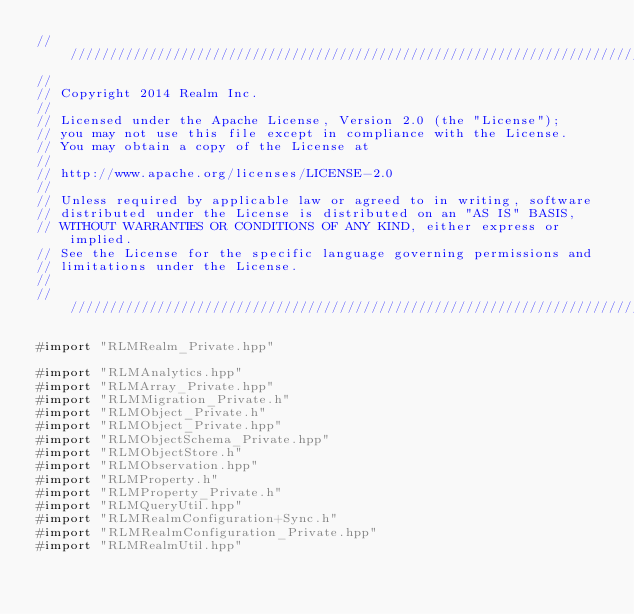Convert code to text. <code><loc_0><loc_0><loc_500><loc_500><_ObjectiveC_>////////////////////////////////////////////////////////////////////////////
//
// Copyright 2014 Realm Inc.
//
// Licensed under the Apache License, Version 2.0 (the "License");
// you may not use this file except in compliance with the License.
// You may obtain a copy of the License at
//
// http://www.apache.org/licenses/LICENSE-2.0
//
// Unless required by applicable law or agreed to in writing, software
// distributed under the License is distributed on an "AS IS" BASIS,
// WITHOUT WARRANTIES OR CONDITIONS OF ANY KIND, either express or implied.
// See the License for the specific language governing permissions and
// limitations under the License.
//
////////////////////////////////////////////////////////////////////////////

#import "RLMRealm_Private.hpp"

#import "RLMAnalytics.hpp"
#import "RLMArray_Private.hpp"
#import "RLMMigration_Private.h"
#import "RLMObject_Private.h"
#import "RLMObject_Private.hpp"
#import "RLMObjectSchema_Private.hpp"
#import "RLMObjectStore.h"
#import "RLMObservation.hpp"
#import "RLMProperty.h"
#import "RLMProperty_Private.h"
#import "RLMQueryUtil.hpp"
#import "RLMRealmConfiguration+Sync.h"
#import "RLMRealmConfiguration_Private.hpp"
#import "RLMRealmUtil.hpp"</code> 